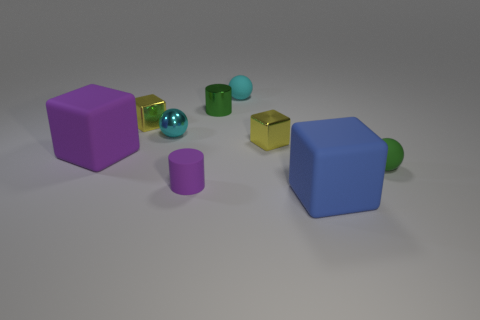Subtract all cubes. How many objects are left? 5 Subtract 1 green cylinders. How many objects are left? 8 Subtract all tiny cyan objects. Subtract all purple objects. How many objects are left? 5 Add 4 rubber cylinders. How many rubber cylinders are left? 5 Add 8 tiny cyan shiny objects. How many tiny cyan shiny objects exist? 9 